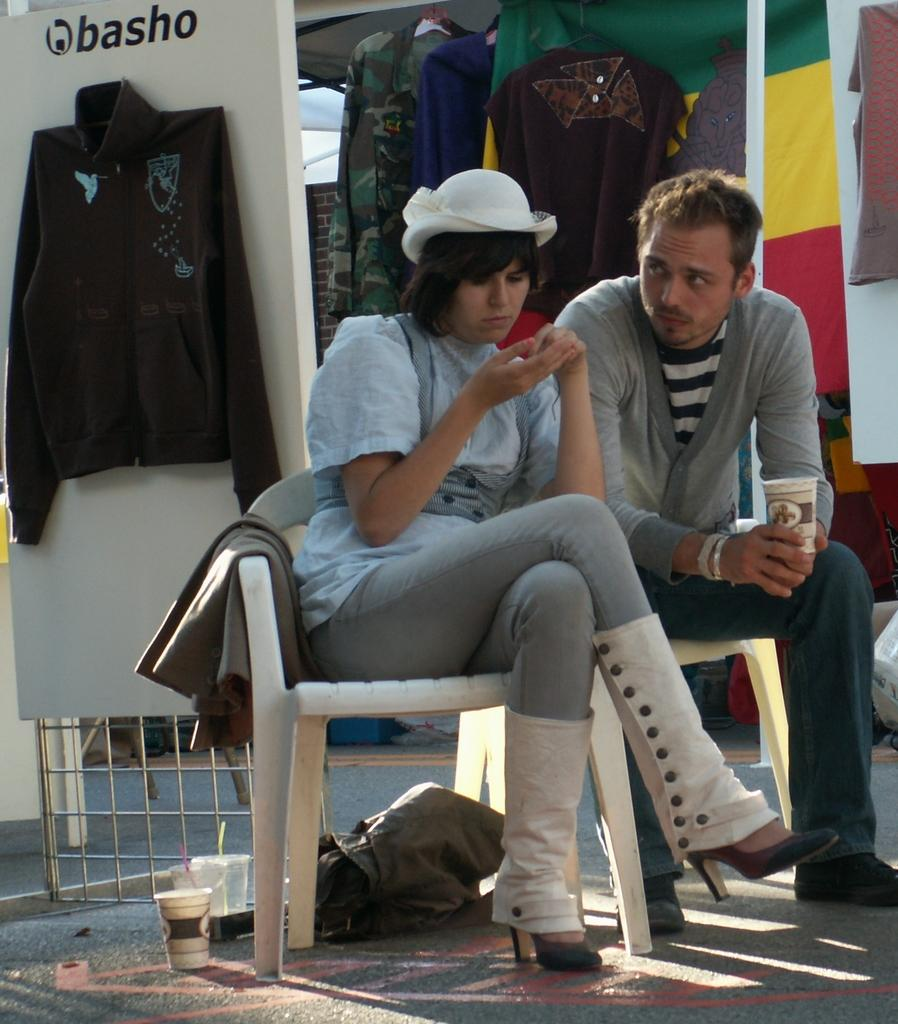How many people are in the image? There are two people in the image. Can you describe the individuals in the image? One person is a man, and the other is a woman. What are the people in the image doing? Both the man and the woman are seated on chairs. What can be seen behind the people in the image? There are clothes hanging at their back. What type of religious ceremony is taking place in the image? There is no indication of a religious ceremony in the image; it simply shows two people seated on chairs with clothes hanging behind them. How many babies are present in the image? There are no babies present in the image. 